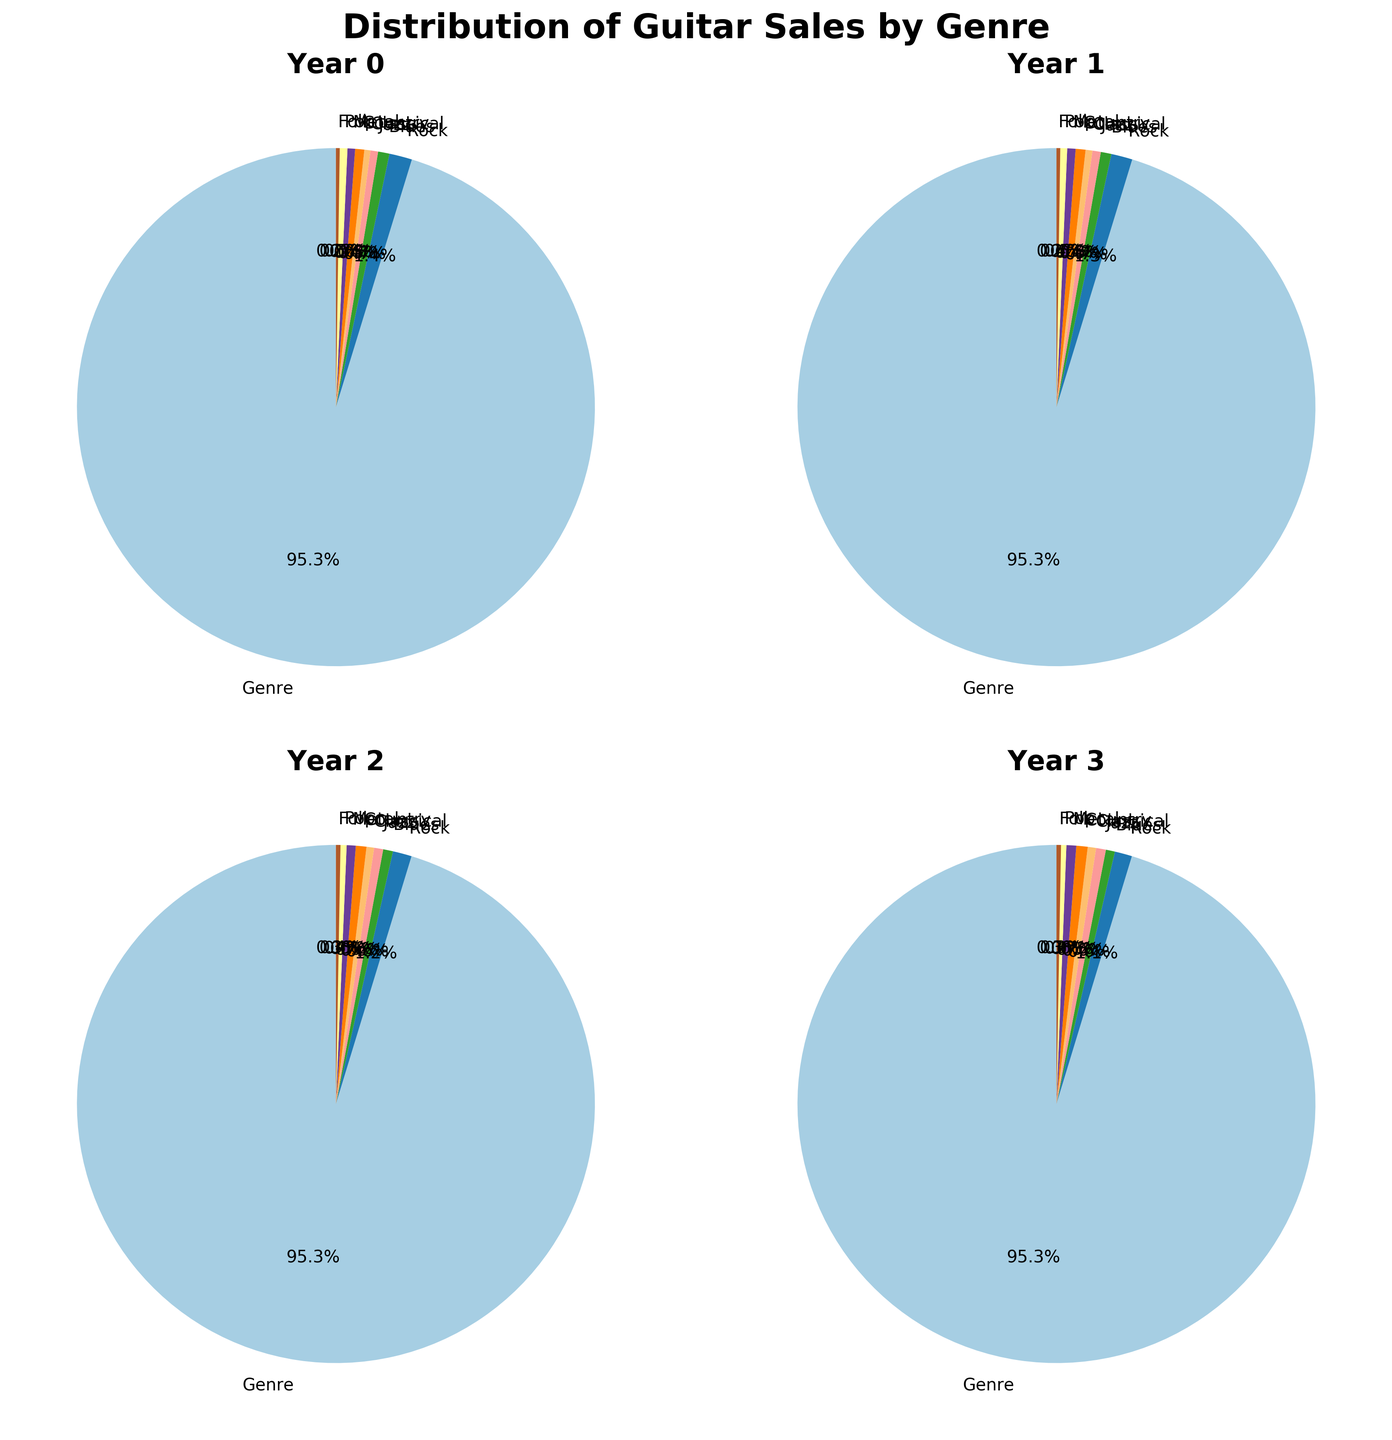Which year had the highest percentage of guitar sales in the Country genre? Look at each pie chart for the percentage of Country genre sales. Compare the values: 12% (2010), 13% (2015), 14% (2020), 15% (2025). 2025 has the highest percentage.
Answer: 2025 Which genre saw the greatest increase in percentage sales from 2010 to 2025? Calculate the difference in percentages for each genre: Rock (-7%), Blues (-3%), Jazz (+3%), Classical (+3%), Country (+3%), Metal (+3%), Pop (-3%), Folk (+1%). Jazz, Classical, Country, and Metal all increased by 3%, but no genre exceeds this increase.
Answer: Jazz, Classical, Country, Metal Which genre had the lowest percentage of guitar sales in 2020? Look at the pie chart for 2020 and identify the genre with the smallest slice. Folk has the smallest slice at 6%.
Answer: Folk By how many percentage points did the Rock genre's sales decrease from 2010 to 2025? Subtract the percentage of Rock sales in 2025 from the percentage in 2010. So, 30% (2010) - 23% (2025) = 7%.
Answer: 7 Which genre consistently held the same percentage of sales over the years? Review the charts for each year's distribution. Folk holds steady at nearly 5-6% every year.
Answer: Folk Compare the sales percentage of Metal and Jazz genres in 2010. Which one is higher and by how much? Look at the pie chart for 2010: Metal (10%), Jazz (10%). The difference is 0%.
Answer: Equal What is the trend in the percentage of sales for the Blues genre from 2010 to 2025? Look at the pie charts for each year to see the percentages: 15% (2010), 14% (2015), 13% (2020), 12% (2025). The trend shows a steady decrease.
Answer: Decreasing By how many percentage points did Classical genre sales increase from 2010 to 2025? Subtract the percentage of Classical sales in 2010 from the percentage in 2025. So, 11% (2025) - 8% (2010) = 3%.
Answer: 3 